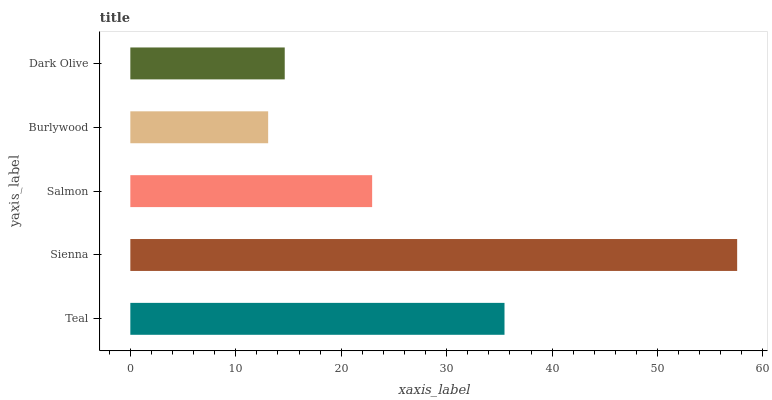Is Burlywood the minimum?
Answer yes or no. Yes. Is Sienna the maximum?
Answer yes or no. Yes. Is Salmon the minimum?
Answer yes or no. No. Is Salmon the maximum?
Answer yes or no. No. Is Sienna greater than Salmon?
Answer yes or no. Yes. Is Salmon less than Sienna?
Answer yes or no. Yes. Is Salmon greater than Sienna?
Answer yes or no. No. Is Sienna less than Salmon?
Answer yes or no. No. Is Salmon the high median?
Answer yes or no. Yes. Is Salmon the low median?
Answer yes or no. Yes. Is Dark Olive the high median?
Answer yes or no. No. Is Sienna the low median?
Answer yes or no. No. 